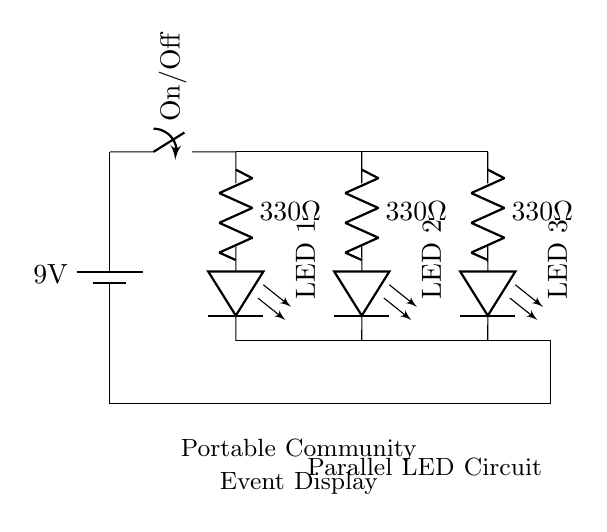What is the voltage of the battery? The circuit shows a battery labeled with a voltage of 9 volts, which supplies power to the entire circuit.
Answer: 9 volts How many LEDs are in the circuit? The circuit diagram illustrates three parallel branches, each containing one LED, totaling three separate LEDs.
Answer: Three What is the resistance of each resistor? The circuit includes three resistors, each labeled with a resistance of 330 ohms, indicating that all resistors have the same resistance value.
Answer: 330 ohms What is the configuration of the LEDs? The LEDs are arranged in a parallel configuration, as evident from the multiple branches that connect to the same voltage source.
Answer: Parallel What happens to the brightness of LEDs if one LED burns out? Since the circuit is designed in parallel, if one LED fails, the others will continue to operate at the same brightness, as each LED has its own path to the power source.
Answer: Remains the same What type of switch is used in the circuit? The circuit uses a simple on/off switch, shown in a vertical orientation, controlling the flow of electricity to the entire circuit.
Answer: On/off switch 